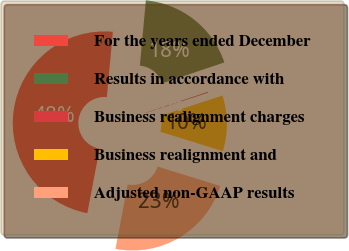<chart> <loc_0><loc_0><loc_500><loc_500><pie_chart><fcel>For the years ended December<fcel>Results in accordance with<fcel>Business realignment charges<fcel>Business realignment and<fcel>Adjusted non-GAAP results<nl><fcel>48.46%<fcel>18.37%<fcel>0.15%<fcel>9.81%<fcel>23.2%<nl></chart> 